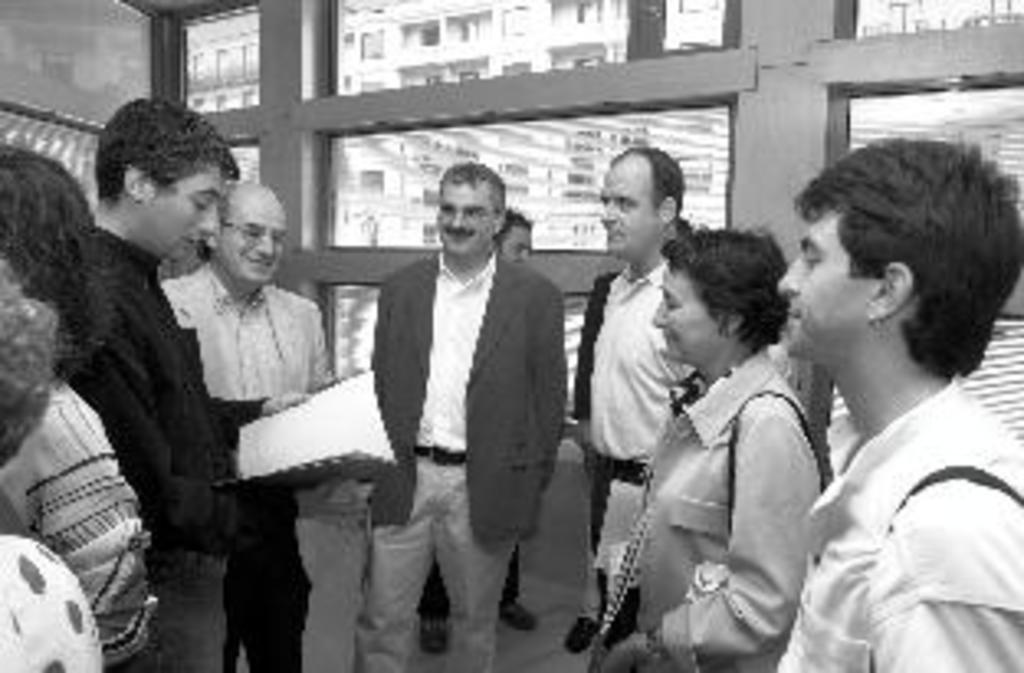What is the color scheme of the image? The image is black and white. Can you describe the people in the image? There are persons in the image. What is one person doing with their hands? One person is holding a book with their hands. What can be seen in the background of the image? There are buildings visible in the background through a glass. How does the person holding the book kick the ball in the image? There is no ball present in the image, so the person cannot kick a ball. 